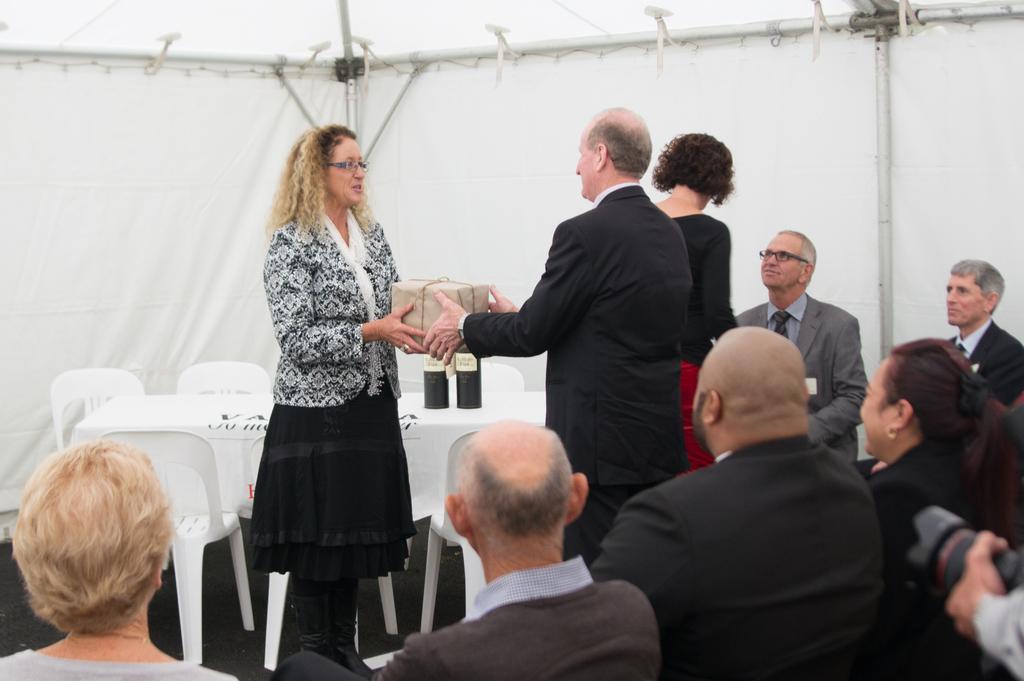Could you give a brief overview of what you see in this image? In the picture we can see some people are sitting on the chairs and one and woman are standing, man is giving something kind of box to the woman and in the background, we can see some table and chairs and behind it we can sees tent walls with some poles. 